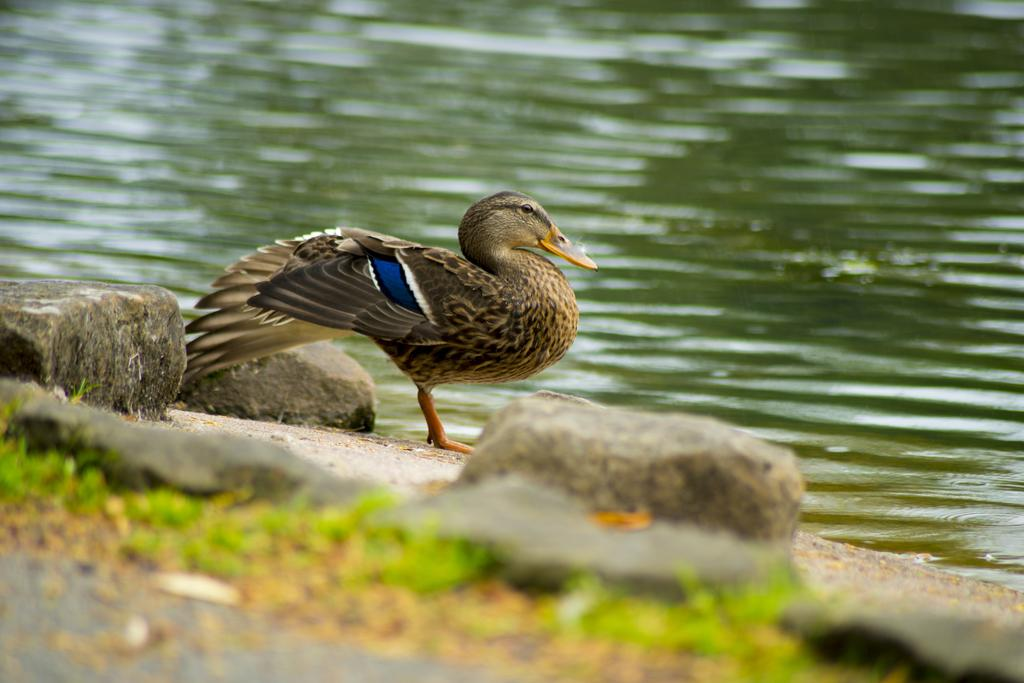What animal is present in the picture? There is a duck in the picture. What other objects or features can be seen near the duck? There are rocks beside the duck. What natural element is visible in the picture? There is water visible in the picture. How many pigs are visible in the picture? There are no pigs present in the picture; it features a duck and rocks near water. 